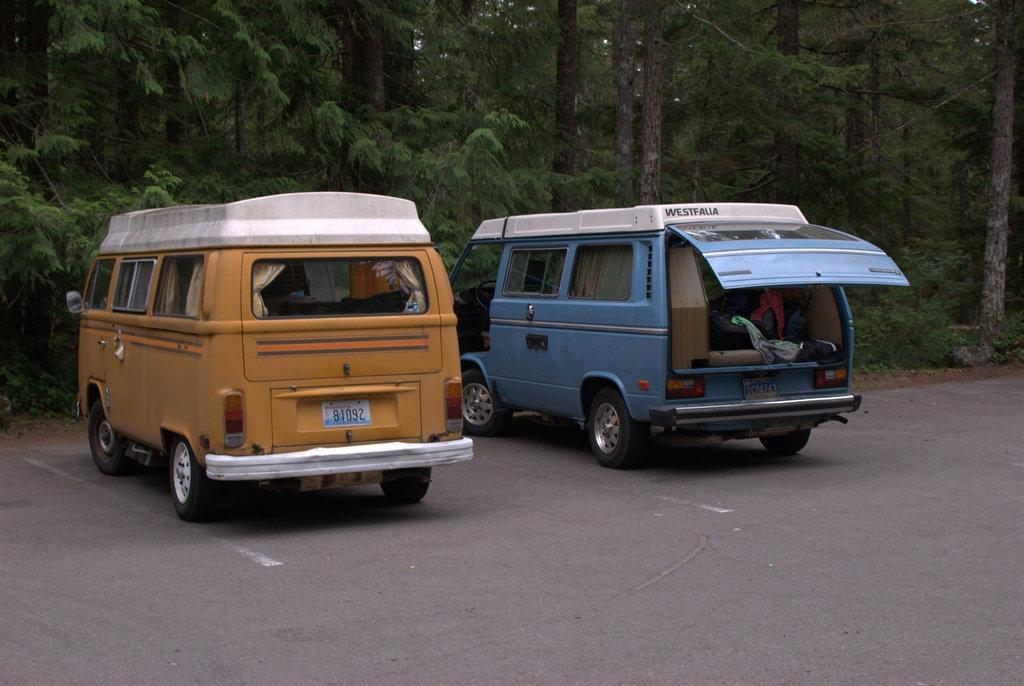How many vehicles can be seen in the image? There are two vehicles in the image. Where are the vehicles located? The vehicles are parked on the road. What is visible in the background of the image? The vehicles are in front of a forest. What is the condition of the backdoor of one of the vehicles? The backdoor of one of the vehicles is open. What can be seen inside the vehicle with the open backdoor? There are items inside the vehicle with the open backdoor. How many cats are sitting on the cord in the image? There are no cats or cords present in the image. 